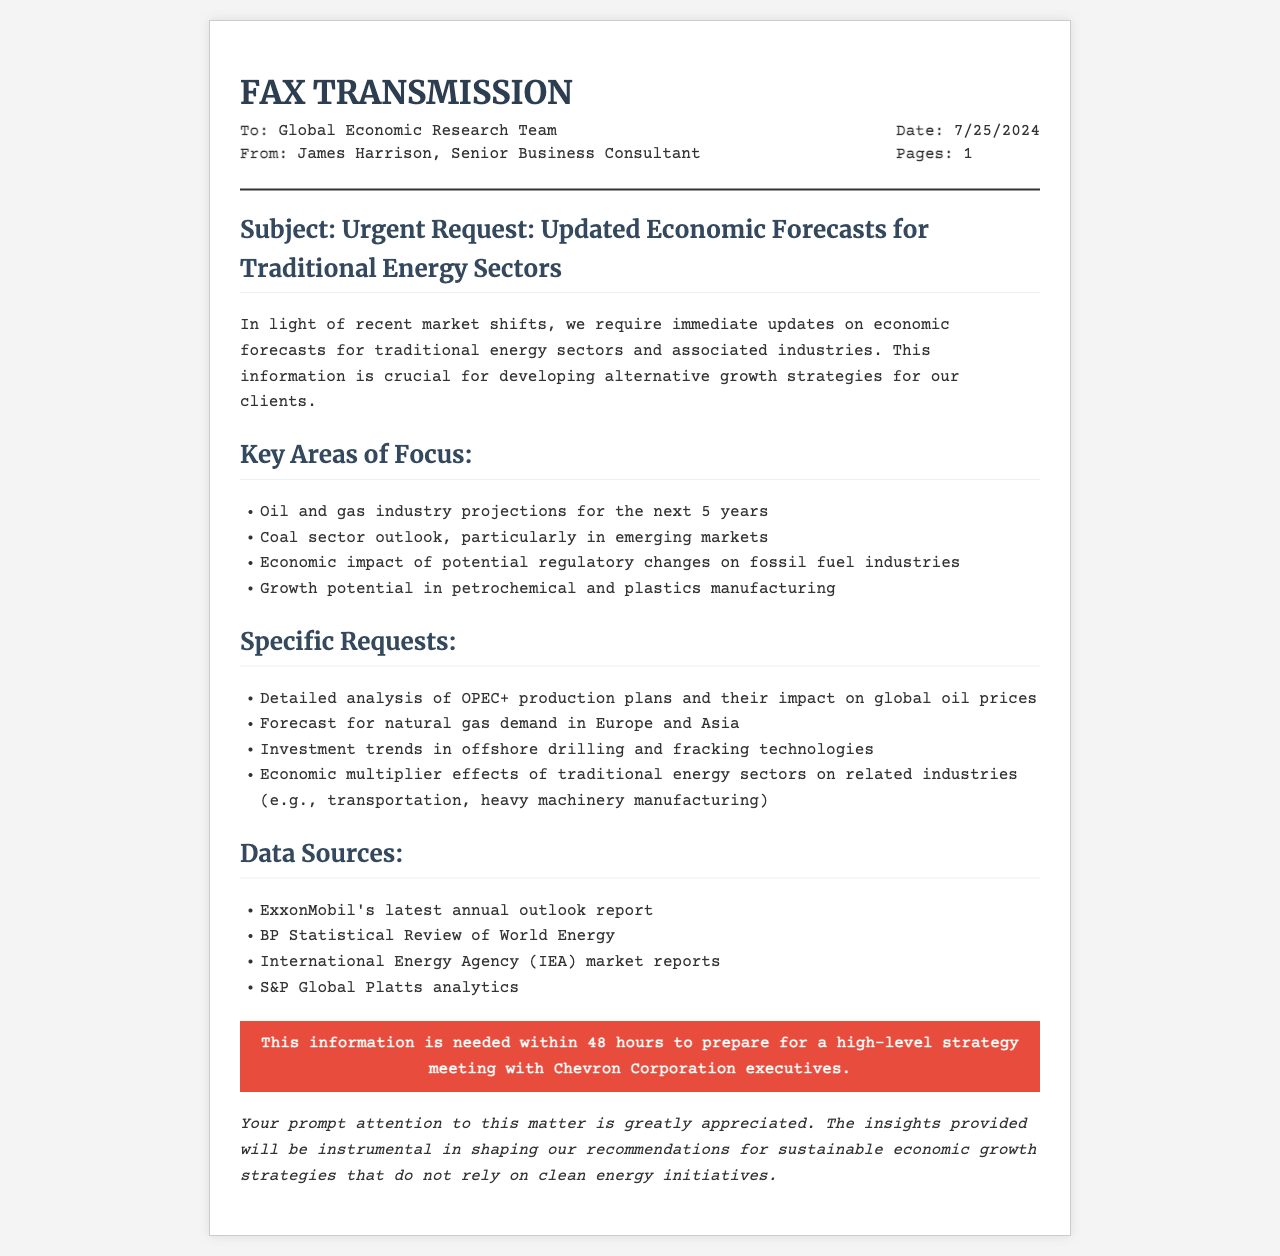what is the date of the fax? The date is dynamically generated, indicating the day the fax is sent, which will be visible when the document is rendered.
Answer: current date who is the sender of the fax? The sender's name is mentioned in the fax transmission details.
Answer: James Harrison what is the main subject of the fax? The subject of the fax is outlined clearly in the subject section.
Answer: Urgent Request: Updated Economic Forecasts for Traditional Energy Sectors how many key areas of focus are listed? The total number of key areas of focus can be counted in the content section.
Answer: four which industry projection is requested for the next five years? One specific request relates to the projections for the oil and gas industry over a defined timeframe.
Answer: Oil and gas industry projections what is the urgency of the information request? The urgency is stated in a specific part of the document, emphasizing the time sensitivity.
Answer: within 48 hours name one data source mentioned. The document lists various sources of data for the requested forecasts and analyses.
Answer: ExxonMobil's latest annual outlook report what is the purpose of the requested economic forecasts? The purpose is indicated in the opening paragraph of the content section.
Answer: alternative growth strategies how many specific requests are listed? The specific requests are detailed in their own section and can be counted.
Answer: four 